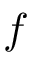<formula> <loc_0><loc_0><loc_500><loc_500>f</formula> 